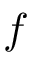<formula> <loc_0><loc_0><loc_500><loc_500>f</formula> 